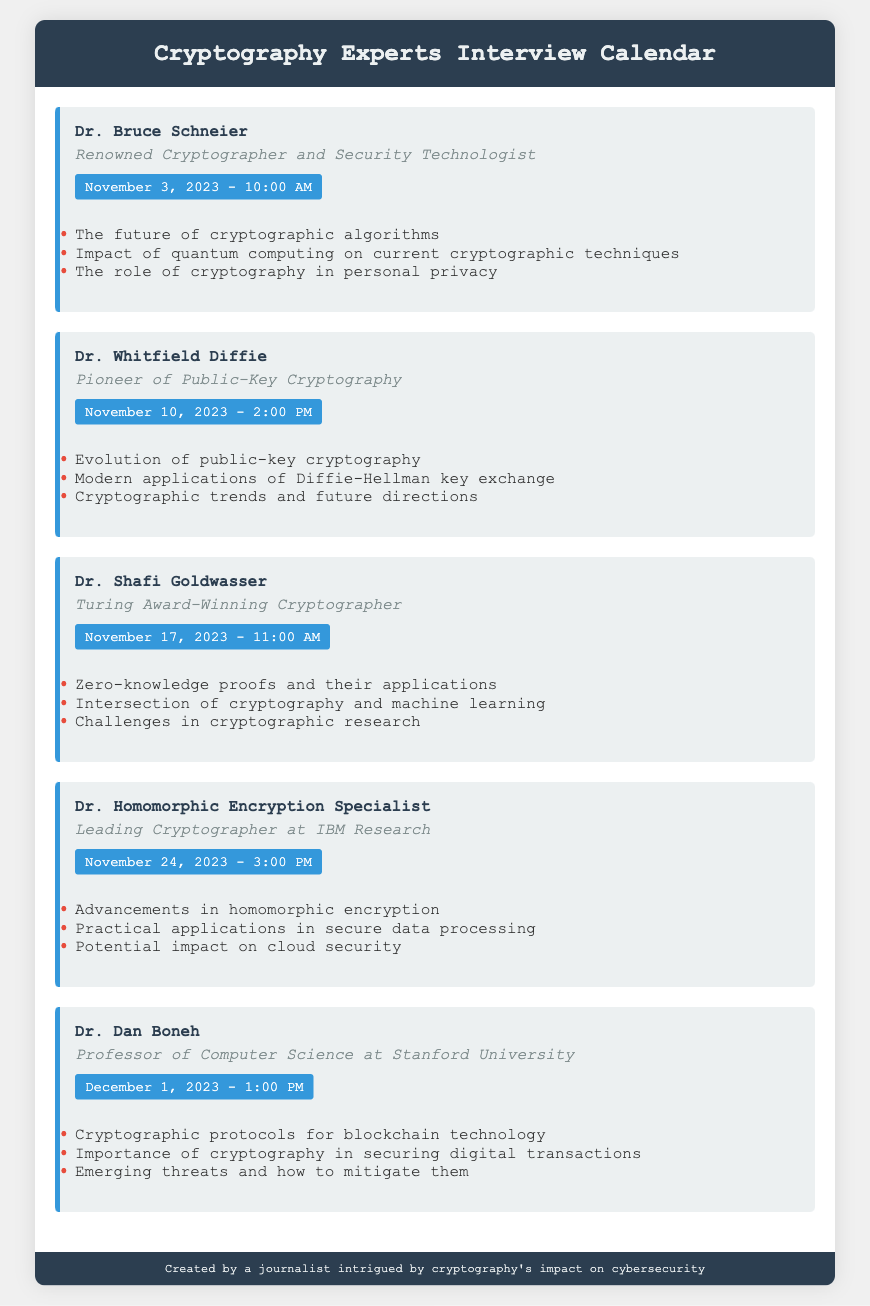What is the date of the appointment with Dr. Bruce Schneier? The date is listed in the document as November 3, 2023.
Answer: November 3, 2023 What is Dr. Whitfield Diffie's title? The title of Dr. Whitfield Diffie is mentioned in the document as "Pioneer of Public-Key Cryptography."
Answer: Pioneer of Public-Key Cryptography At what time is Dr. Shafi Goldwasser's appointment scheduled? The document specifies the time for Dr. Shafi Goldwasser's appointment as 11:00 AM.
Answer: 11:00 AM What is the focus of Dr. Homomorphic Encryption Specialist's discussion? The document outlines key discussion points, including "Advancements in homomorphic encryption."
Answer: Advancements in homomorphic encryption How many cryptography experts are listed in the calendar? The total number of experts is indicated by the number of appointment sections present in the document, which is five.
Answer: Five Which expert is associated with the topic of blockchain technology? The document lists Dr. Dan Boneh as the expert discussing "Cryptographic protocols for blockchain technology."
Answer: Dr. Dan Boneh What common theme is present in all discussions? The common theme revolves around the role and impact of various aspects of cryptography in modern technology and security.
Answer: Cryptography's role in modern technology What is the scheduled appointment time with Dr. Dan Boneh? The time for Dr. Dan Boneh's appointment is clearly stated as 1:00 PM in the document.
Answer: 1:00 PM What key trend in cryptography is highlighted by Dr. Whitfield Diffie? The document mentions "Cryptographic trends and future directions" as a point of discussion with Dr. Whitfield Diffie.
Answer: Cryptographic trends and future directions 